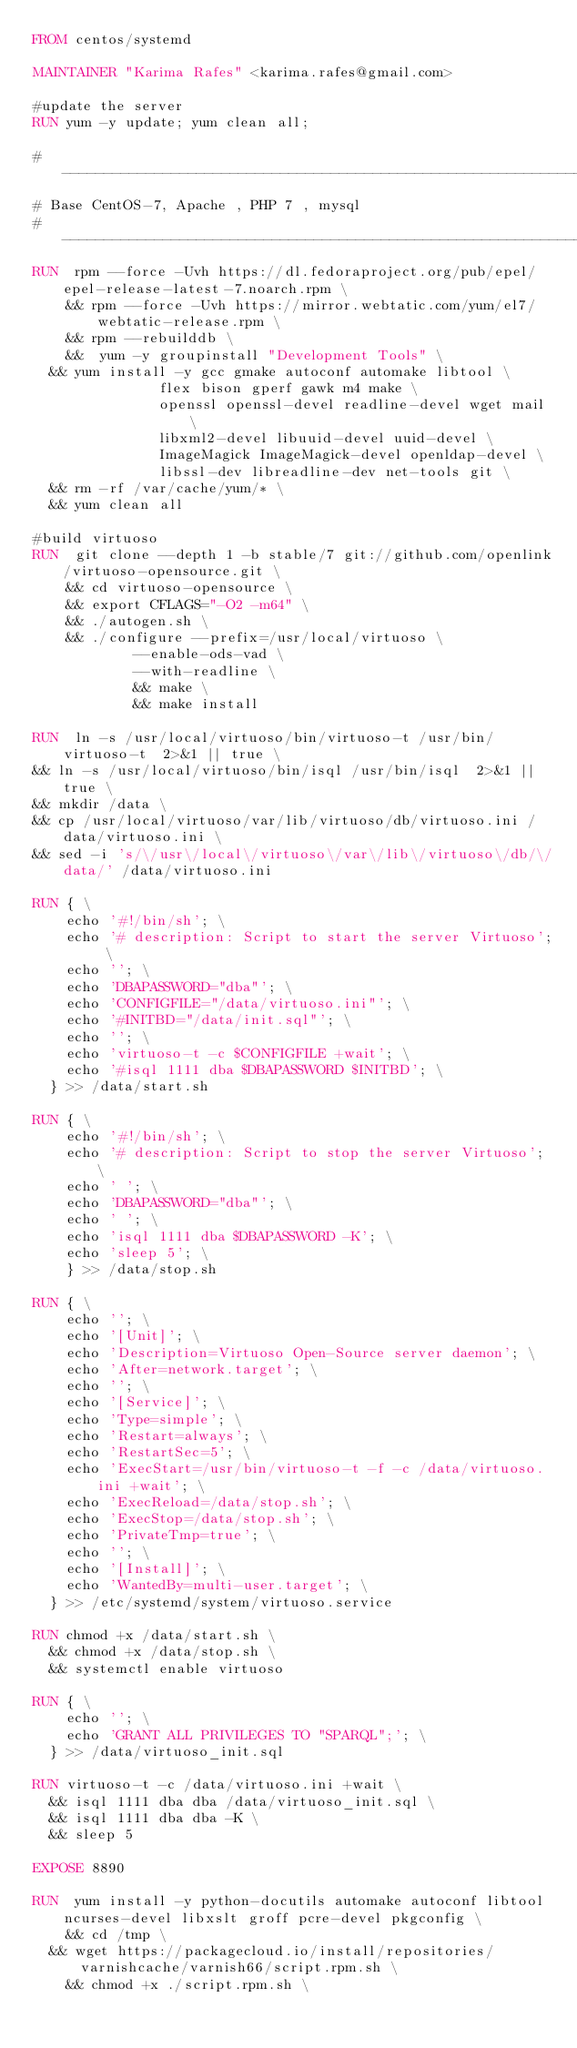Convert code to text. <code><loc_0><loc_0><loc_500><loc_500><_Dockerfile_>FROM centos/systemd

MAINTAINER "Karima Rafes" <karima.rafes@gmail.com>

#update the server
RUN yum -y update; yum clean all;

# -----------------------------------------------------------------------------
# Base CentOS-7, Apache , PHP 7 , mysql
# -----------------------------------------------------------------------------
RUN  rpm --force -Uvh https://dl.fedoraproject.org/pub/epel/epel-release-latest-7.noarch.rpm \
    && rpm --force -Uvh https://mirror.webtatic.com/yum/el7/webtatic-release.rpm \
    && rpm --rebuilddb \
    &&  yum -y groupinstall "Development Tools" \
	&& yum install -y gcc gmake autoconf automake libtool \
               flex bison gperf gawk m4 make \
               openssl openssl-devel readline-devel wget mail \
               libxml2-devel libuuid-devel uuid-devel \
               ImageMagick ImageMagick-devel openldap-devel \
               libssl-dev libreadline-dev net-tools git \
	&& rm -rf /var/cache/yum/* \
	&& yum clean all

#build virtuoso
RUN  git clone --depth 1 -b stable/7 git://github.com/openlink/virtuoso-opensource.git \
    && cd virtuoso-opensource \
    && export CFLAGS="-O2 -m64" \
    && ./autogen.sh \
    && ./configure --prefix=/usr/local/virtuoso \
            --enable-ods-vad \
            --with-readline \
            && make \
            && make install

RUN  ln -s /usr/local/virtuoso/bin/virtuoso-t /usr/bin/virtuoso-t  2>&1 || true \
&& ln -s /usr/local/virtuoso/bin/isql /usr/bin/isql  2>&1 || true \
&& mkdir /data \
&& cp /usr/local/virtuoso/var/lib/virtuoso/db/virtuoso.ini /data/virtuoso.ini \
&& sed -i 's/\/usr\/local\/virtuoso\/var\/lib\/virtuoso\/db/\/data/' /data/virtuoso.ini

RUN { \
		echo '#!/bin/sh'; \
		echo '# description: Script to start the server Virtuoso'; \
		echo ''; \
		echo 'DBAPASSWORD="dba"'; \
		echo 'CONFIGFILE="/data/virtuoso.ini"'; \
		echo '#INITBD="/data/init.sql"'; \
		echo ''; \
		echo 'virtuoso-t -c $CONFIGFILE +wait'; \
		echo '#isql 1111 dba $DBAPASSWORD $INITBD'; \
	} >> /data/start.sh

RUN { \
		echo '#!/bin/sh'; \
		echo '# description: Script to stop the server Virtuoso'; \
		echo ' '; \
		echo 'DBAPASSWORD="dba"'; \
		echo ' '; \
		echo 'isql 1111 dba $DBAPASSWORD -K'; \
		echo 'sleep 5'; \
		} >> /data/stop.sh

RUN { \
		echo ''; \
		echo '[Unit]'; \
		echo 'Description=Virtuoso Open-Source server daemon'; \
		echo 'After=network.target'; \
		echo ''; \
		echo '[Service]'; \
		echo 'Type=simple'; \
		echo 'Restart=always'; \
		echo 'RestartSec=5'; \
		echo 'ExecStart=/usr/bin/virtuoso-t -f -c /data/virtuoso.ini +wait'; \
		echo 'ExecReload=/data/stop.sh'; \
		echo 'ExecStop=/data/stop.sh'; \
		echo 'PrivateTmp=true'; \
		echo ''; \
		echo '[Install]'; \
		echo 'WantedBy=multi-user.target'; \
	} >> /etc/systemd/system/virtuoso.service

RUN chmod +x /data/start.sh \
	&& chmod +x /data/stop.sh \
	&& systemctl enable virtuoso

RUN { \
		echo ''; \
		echo 'GRANT ALL PRIVILEGES TO "SPARQL";'; \
	} >> /data/virtuoso_init.sql

RUN virtuoso-t -c /data/virtuoso.ini +wait \
	&& isql 1111 dba dba /data/virtuoso_init.sql \
	&& isql 1111 dba dba -K \
	&& sleep 5

EXPOSE 8890

RUN  yum install -y python-docutils automake autoconf libtool ncurses-devel libxslt groff pcre-devel pkgconfig \
    && cd /tmp \
	&& wget https://packagecloud.io/install/repositories/varnishcache/varnish66/script.rpm.sh \
    && chmod +x ./script.rpm.sh \</code> 